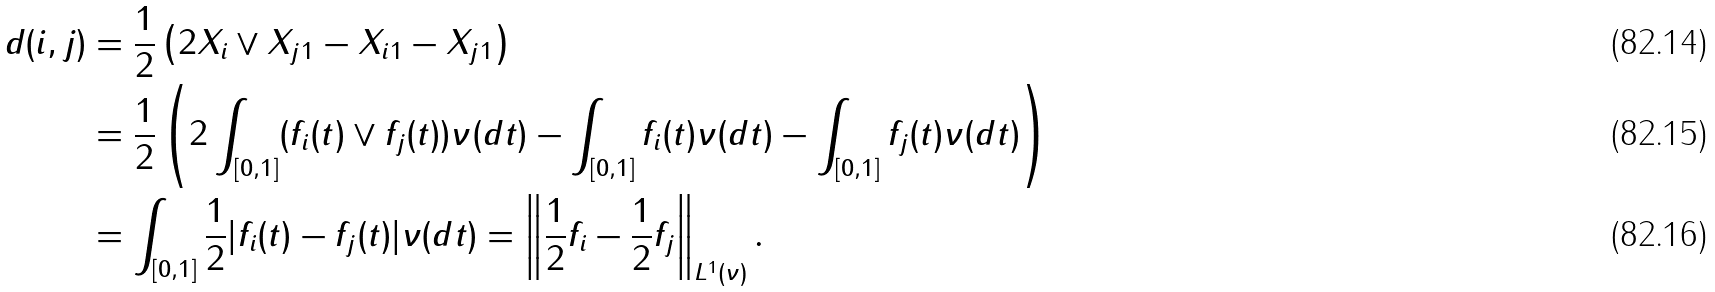Convert formula to latex. <formula><loc_0><loc_0><loc_500><loc_500>d ( i , j ) & = \frac { 1 } { 2 } \left ( 2 \| X _ { i } \vee X _ { j } \| _ { 1 } - \| X _ { i } \| _ { 1 } - \| X _ { j } \| _ { 1 } \right ) \\ & = \frac { 1 } { 2 } \left ( 2 \int _ { [ 0 , 1 ] } ( f _ { i } ( t ) \vee f _ { j } ( t ) ) \nu ( d t ) - \int _ { [ 0 , 1 ] } f _ { i } ( t ) \nu ( d t ) - \int _ { [ 0 , 1 ] } f _ { j } ( t ) \nu ( d t ) \right ) \\ & = \int _ { [ 0 , 1 ] } \frac { 1 } { 2 } | f _ { i } ( t ) - f _ { j } ( t ) | \nu ( d t ) = \left \| \frac { 1 } { 2 } f _ { i } - \frac { 1 } { 2 } f _ { j } \right \| _ { L ^ { 1 } ( \nu ) } .</formula> 